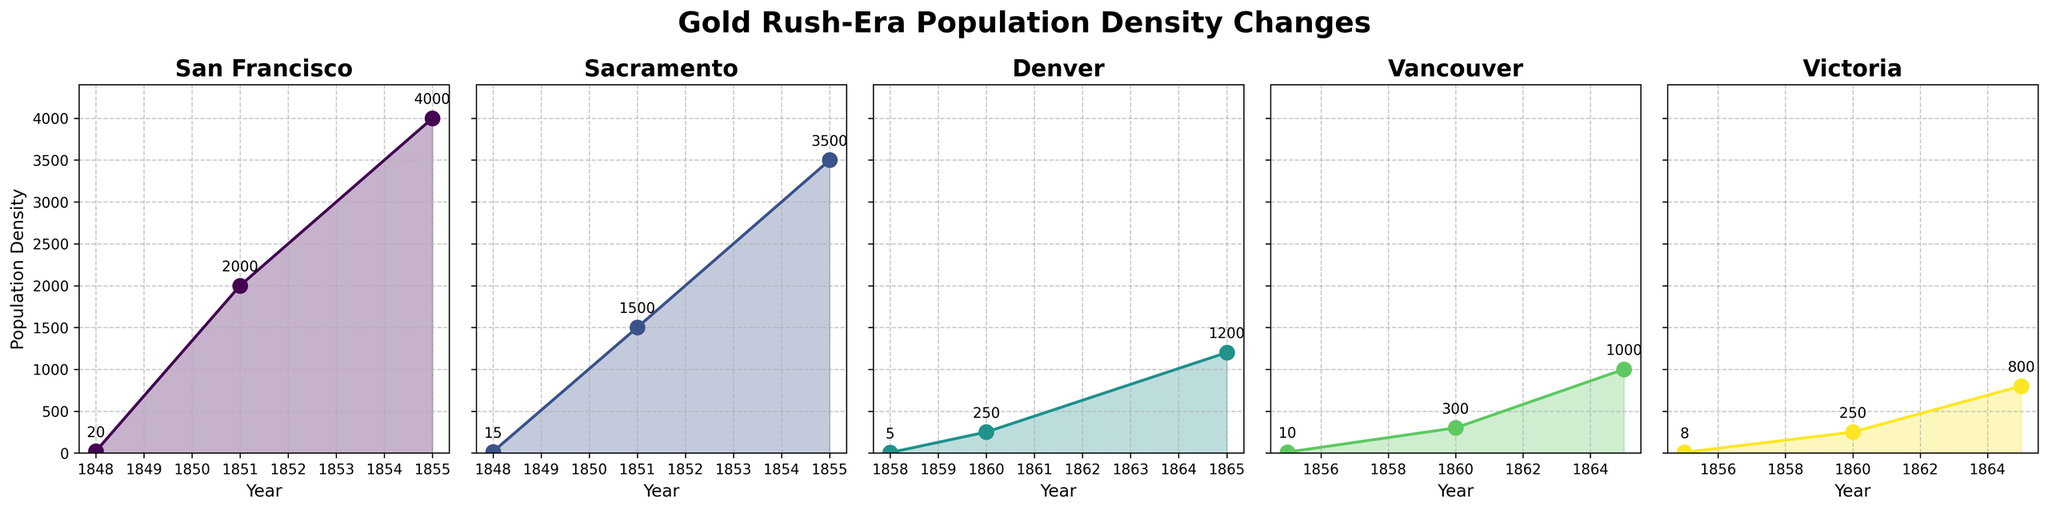What is the title of the plot? The title is seen at the top of the plot and provides an overview of what the plot is displaying.
Answer: Gold Rush-Era Population Density Changes Which region had the highest population density in 1855? The highest population density for each region and year can be determined by looking at the peak points of the lines in the individual subplots for the year 1855.
Answer: San Francisco How did the population density of Sacramento change from 1848 to 1855? Look at the line plot for Sacramento and note the population densities for the years 1848 and 1855, then find the difference. In 1848 it was 15, and in 1855 it was 3500. The density increased by 3500 - 15 = 3485.
Answer: Increased by 3485 Compare the population density growth between Victoria and Vancouver from 1860 to 1865. For Victoria, the population density grew from 250 to 800. For Vancouver, it grew from 300 to 1000. Calculate the growth by subtracting the earlier year from the later year for both regions (800-250=550 for Victoria, 1000-300=700 for Vancouver).
Answer: Vancouver had a higher growth (700 vs 550) Which region shows the earliest indication of significant population density increase? The earliest indication of a significant increase can be observed by finding the region that first shows a sharp rise in population density in the earliest years. San Francisco shows a sharp rise from 1848 to 1851.
Answer: San Francisco What is the trend of population density in Denver from 1858 to 1865? Look at the plotted line for Denver across the years 1858, 1860, and 1865. The population density rose from 5 in 1858 to 1200 in 1865.
Answer: Increasing By what multiple did San Francisco’s population density increase from 1848 to 1855? To find the multiple, divide the population density in 1855 by that of 1848. For San Francisco: 4000 / 20 = 200.
Answer: 200 Which region had the lowest population density in 1848 and what was its value? The lowest value can be found by looking at the population density values for each region in 1848. Only San Francisco and Sacramento have data for 1848. Sacramento had 15, lower than San Francisco's 20.
Answer: Sacramento, 15 How much did the population density in Denver increase between 1860 and 1865? Subtract the population density in 1860 from that in 1865 for Denver: 1200 - 250 = 950.
Answer: 950 